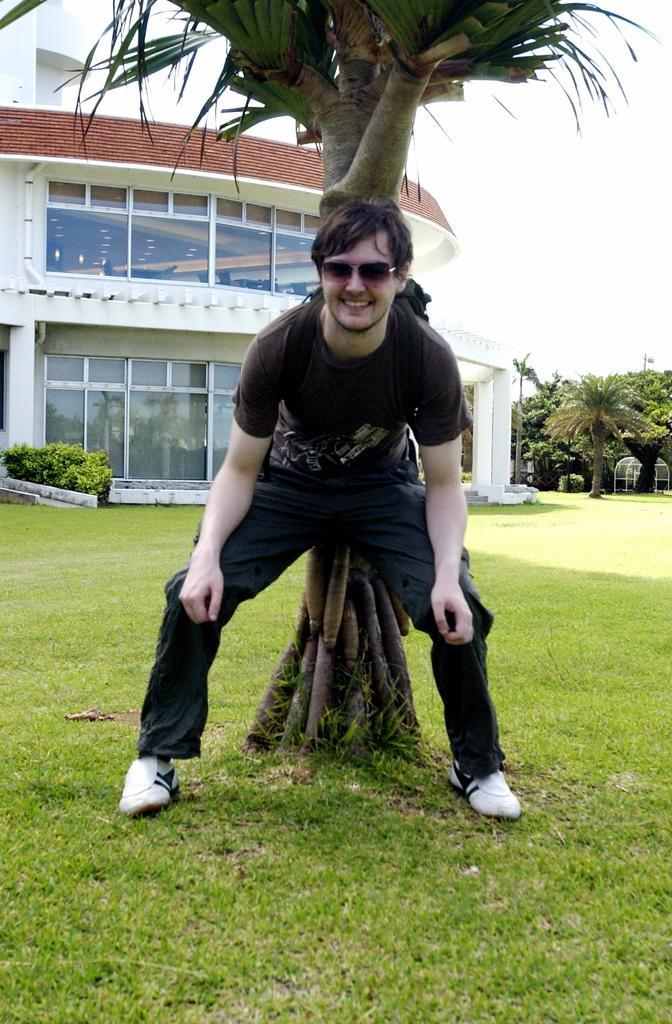Could you give a brief overview of what you see in this image? In this image, we can see a person wearing spectacles. We can see the ground with some grass. We can see some trees, plants and the sky. We can also see a object. 